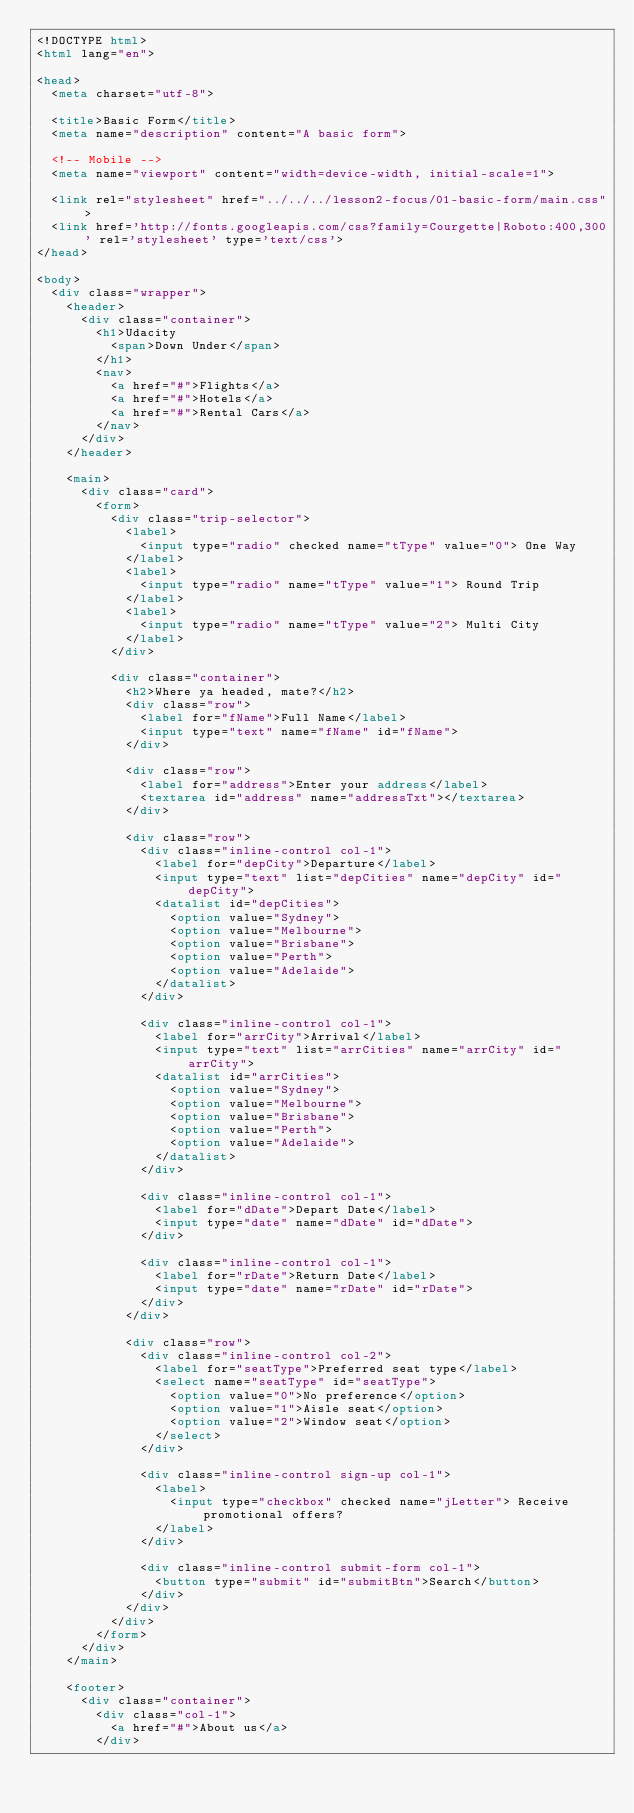<code> <loc_0><loc_0><loc_500><loc_500><_HTML_><!DOCTYPE html>
<html lang="en">

<head>
  <meta charset="utf-8">

  <title>Basic Form</title>
  <meta name="description" content="A basic form">

  <!-- Mobile -->
  <meta name="viewport" content="width=device-width, initial-scale=1">

  <link rel="stylesheet" href="../../../lesson2-focus/01-basic-form/main.css">
  <link href='http://fonts.googleapis.com/css?family=Courgette|Roboto:400,300' rel='stylesheet' type='text/css'>
</head>

<body>
  <div class="wrapper">
    <header>
      <div class="container">
        <h1>Udacity
          <span>Down Under</span>
        </h1>
        <nav>
          <a href="#">Flights</a>
          <a href="#">Hotels</a>
          <a href="#">Rental Cars</a>
        </nav>
      </div>
    </header>

    <main>
      <div class="card">
        <form>
          <div class="trip-selector">
            <label>
              <input type="radio" checked name="tType" value="0"> One Way
            </label>
            <label>
              <input type="radio" name="tType" value="1"> Round Trip
            </label>
            <label>
              <input type="radio" name="tType" value="2"> Multi City
            </label>
          </div>

          <div class="container">
            <h2>Where ya headed, mate?</h2>
            <div class="row">
              <label for="fName">Full Name</label>
              <input type="text" name="fName" id="fName">
            </div>

            <div class="row">
              <label for="address">Enter your address</label>
              <textarea id="address" name="addressTxt"></textarea>
            </div>

            <div class="row">
              <div class="inline-control col-1">
                <label for="depCity">Departure</label>
                <input type="text" list="depCities" name="depCity" id="depCity">
                <datalist id="depCities">
                  <option value="Sydney">
                  <option value="Melbourne">
                  <option value="Brisbane">
                  <option value="Perth">
                  <option value="Adelaide">
                </datalist>
              </div>

              <div class="inline-control col-1">
                <label for="arrCity">Arrival</label>
                <input type="text" list="arrCities" name="arrCity" id="arrCity">
                <datalist id="arrCities">
                  <option value="Sydney">
                  <option value="Melbourne">
                  <option value="Brisbane">
                  <option value="Perth">
                  <option value="Adelaide">
                </datalist>
              </div>

              <div class="inline-control col-1">
                <label for="dDate">Depart Date</label>
                <input type="date" name="dDate" id="dDate">
              </div>

              <div class="inline-control col-1">
                <label for="rDate">Return Date</label>
                <input type="date" name="rDate" id="rDate">
              </div>
            </div>

            <div class="row">
              <div class="inline-control col-2">
                <label for="seatType">Preferred seat type</label>
                <select name="seatType" id="seatType">
                  <option value="0">No preference</option>
                  <option value="1">Aisle seat</option>
                  <option value="2">Window seat</option>
                </select>
              </div>

              <div class="inline-control sign-up col-1">
                <label>
                  <input type="checkbox" checked name="jLetter"> Receive promotional offers?
                </label>
              </div>

              <div class="inline-control submit-form col-1">
                <button type="submit" id="submitBtn">Search</button>
              </div>
            </div>
          </div>
        </form>
      </div>
    </main>

    <footer>
      <div class="container">
        <div class="col-1">
          <a href="#">About us</a>
        </div></code> 